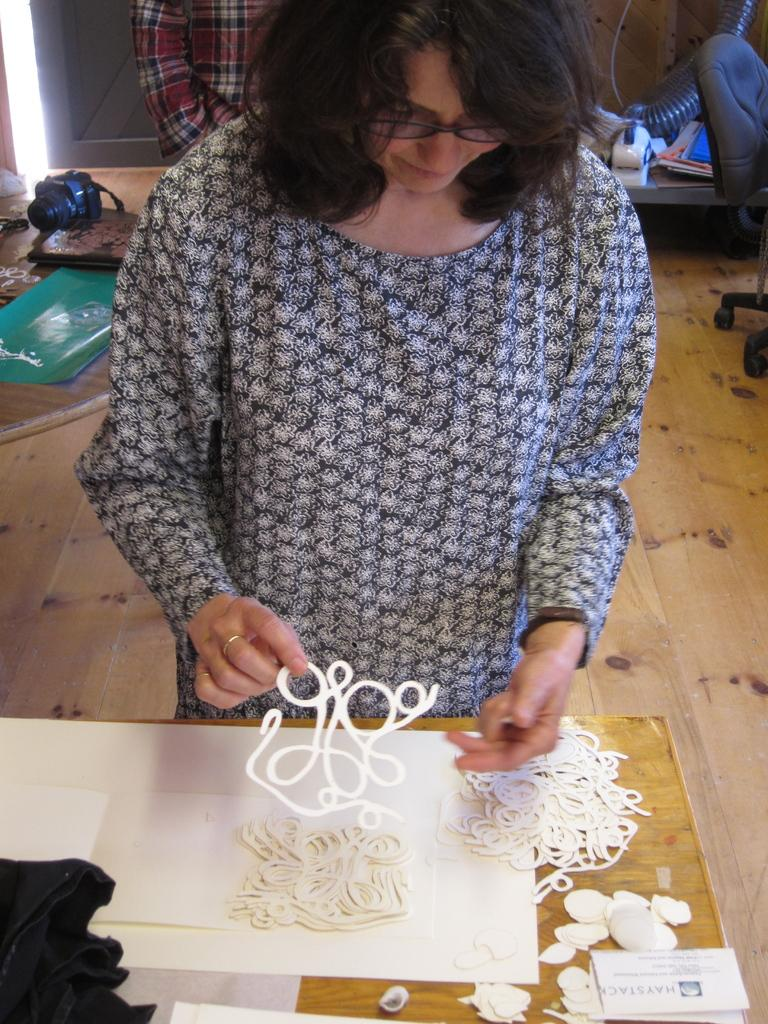How many people are in the image? There are two persons in the image. What is one person doing in the image? One person is holding an object. What is on the table in the image? There is a table with objects on it. Are there any objects on the floor in the image? Yes, there are objects on the floor in the image. What type of soap is being used to clean the chain in the image? There is no soap, chain, or hook present in the image. 